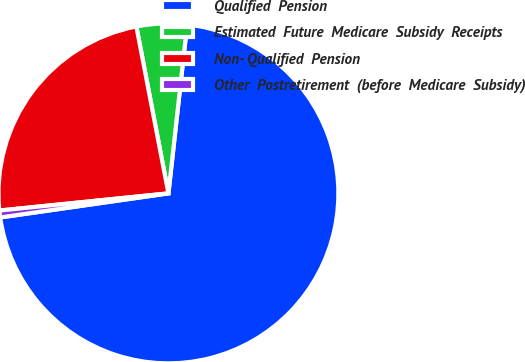Convert chart. <chart><loc_0><loc_0><loc_500><loc_500><pie_chart><fcel>Qualified  Pension<fcel>Estimated  Future  Medicare  Subsidy  Receipts<fcel>Non- Qualified  Pension<fcel>Other  Postretirement  (before  Medicare  Subsidy)<nl><fcel>70.98%<fcel>4.78%<fcel>23.59%<fcel>0.65%<nl></chart> 